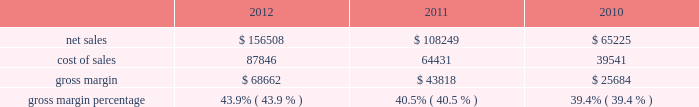$ 43.3 million in 2011 compared to $ 34.1 million in 2010 .
The retail segment represented 13% ( 13 % ) and 15% ( 15 % ) of the company 2019s total net sales in 2011 and 2010 , respectively .
The retail segment 2019s operating income was $ 4.7 billion , $ 3.2 billion , and $ 2.3 billion during 2012 , 2011 , and 2010 respectively .
These year-over-year increases in retail operating income were primarily attributable to higher overall net sales that resulted in significantly higher average revenue per store during the respective years .
Gross margin gross margin for 2012 , 2011 and 2010 are as follows ( in millions , except gross margin percentages ) : .
The gross margin percentage in 2012 was 43.9% ( 43.9 % ) , compared to 40.5% ( 40.5 % ) in 2011 .
This year-over-year increase in gross margin was largely driven by lower commodity and other product costs , a higher mix of iphone sales , and improved leverage on fixed costs from higher net sales .
The increase in gross margin was partially offset by the impact of a stronger u.s .
Dollar .
The gross margin percentage during the first half of 2012 was 45.9% ( 45.9 % ) compared to 41.4% ( 41.4 % ) during the second half of 2012 .
The primary drivers of higher gross margin in the first half of 2012 compared to the second half are a higher mix of iphone sales and improved leverage on fixed costs from higher net sales .
Additionally , gross margin in the second half of 2012 was also affected by the introduction of new products with flat pricing that have higher cost structures and deliver greater value to customers , price reductions on certain existing products , higher transition costs associated with product launches , and continued strengthening of the u.s .
Dollar ; partially offset by lower commodity costs .
The gross margin percentage in 2011 was 40.5% ( 40.5 % ) , compared to 39.4% ( 39.4 % ) in 2010 .
This year-over-year increase in gross margin was largely driven by lower commodity and other product costs .
The company expects to experience decreases in its gross margin percentage in future periods , as compared to levels achieved during 2012 , and the company anticipates gross margin of about 36% ( 36 % ) during the first quarter of 2013 .
Expected future declines in gross margin are largely due to a higher mix of new and innovative products with flat or reduced pricing that have higher cost structures and deliver greater value to customers and anticipated component cost and other cost increases .
Future strengthening of the u.s .
Dollar could further negatively impact gross margin .
The foregoing statements regarding the company 2019s expected gross margin percentage in future periods , including the first quarter of 2013 , are forward-looking and could differ from actual results because of several factors including , but not limited to those set forth above in part i , item 1a of this form 10-k under the heading 201crisk factors 201d and those described in this paragraph .
In general , gross margins and margins on individual products will remain under downward pressure due to a variety of factors , including continued industry wide global product pricing pressures , increased competition , compressed product life cycles , product transitions and potential increases in the cost of components , as well as potential increases in the costs of outside manufacturing services and a potential shift in the company 2019s sales mix towards products with lower gross margins .
In response to competitive pressures , the company expects it will continue to take product pricing actions , which would adversely affect gross margins .
Gross margins could also be affected by the company 2019s ability to manage product quality and warranty costs effectively and to stimulate demand for certain of its products .
Due to the company 2019s significant international operations , financial results can be significantly affected in the short-term by fluctuations in exchange rates. .
What was the increase in gross margin percentage between 2012 compared to 2011? 
Computations: (43.9 - 40.5)
Answer: 3.4. 